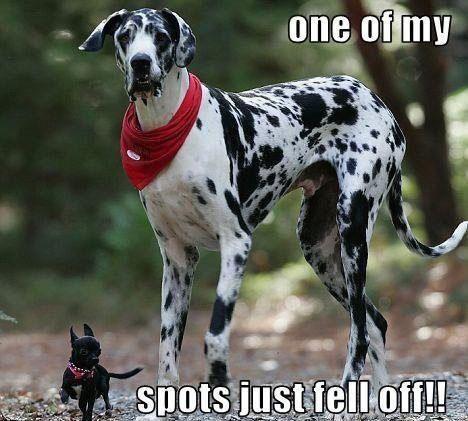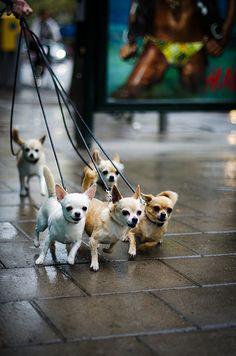The first image is the image on the left, the second image is the image on the right. Considering the images on both sides, is "There are no more than three dogs" valid? Answer yes or no. No. 